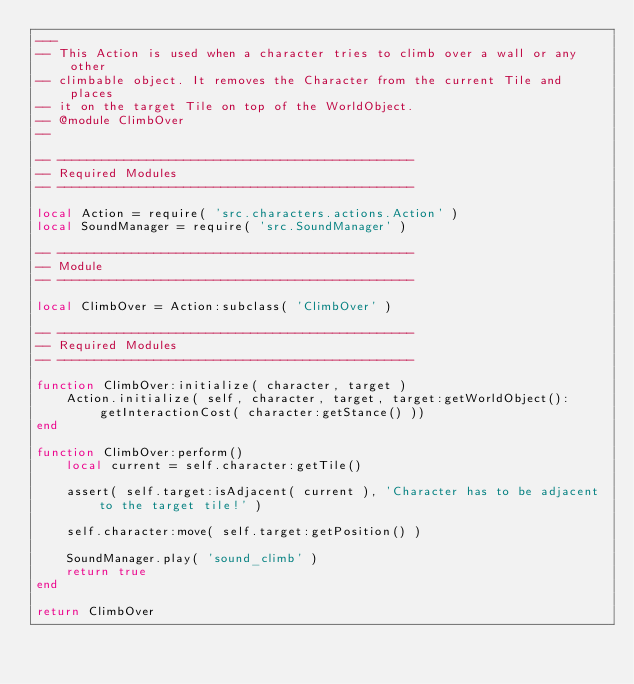Convert code to text. <code><loc_0><loc_0><loc_500><loc_500><_Lua_>---
-- This Action is used when a character tries to climb over a wall or any other
-- climbable object. It removes the Character from the current Tile and places
-- it on the target Tile on top of the WorldObject.
-- @module ClimbOver
--

-- ------------------------------------------------
-- Required Modules
-- ------------------------------------------------

local Action = require( 'src.characters.actions.Action' )
local SoundManager = require( 'src.SoundManager' )

-- ------------------------------------------------
-- Module
-- ------------------------------------------------

local ClimbOver = Action:subclass( 'ClimbOver' )

-- ------------------------------------------------
-- Required Modules
-- ------------------------------------------------

function ClimbOver:initialize( character, target )
    Action.initialize( self, character, target, target:getWorldObject():getInteractionCost( character:getStance() ))
end

function ClimbOver:perform()
    local current = self.character:getTile()

    assert( self.target:isAdjacent( current ), 'Character has to be adjacent to the target tile!' )

    self.character:move( self.target:getPosition() )

    SoundManager.play( 'sound_climb' )
    return true
end

return ClimbOver
</code> 